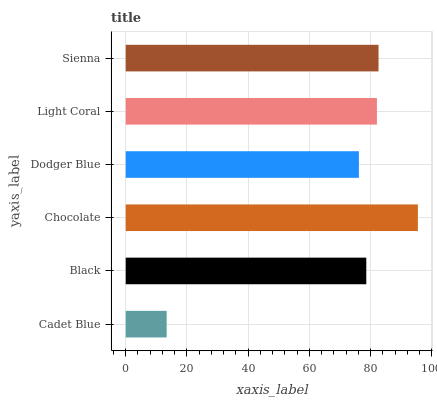Is Cadet Blue the minimum?
Answer yes or no. Yes. Is Chocolate the maximum?
Answer yes or no. Yes. Is Black the minimum?
Answer yes or no. No. Is Black the maximum?
Answer yes or no. No. Is Black greater than Cadet Blue?
Answer yes or no. Yes. Is Cadet Blue less than Black?
Answer yes or no. Yes. Is Cadet Blue greater than Black?
Answer yes or no. No. Is Black less than Cadet Blue?
Answer yes or no. No. Is Light Coral the high median?
Answer yes or no. Yes. Is Black the low median?
Answer yes or no. Yes. Is Chocolate the high median?
Answer yes or no. No. Is Sienna the low median?
Answer yes or no. No. 